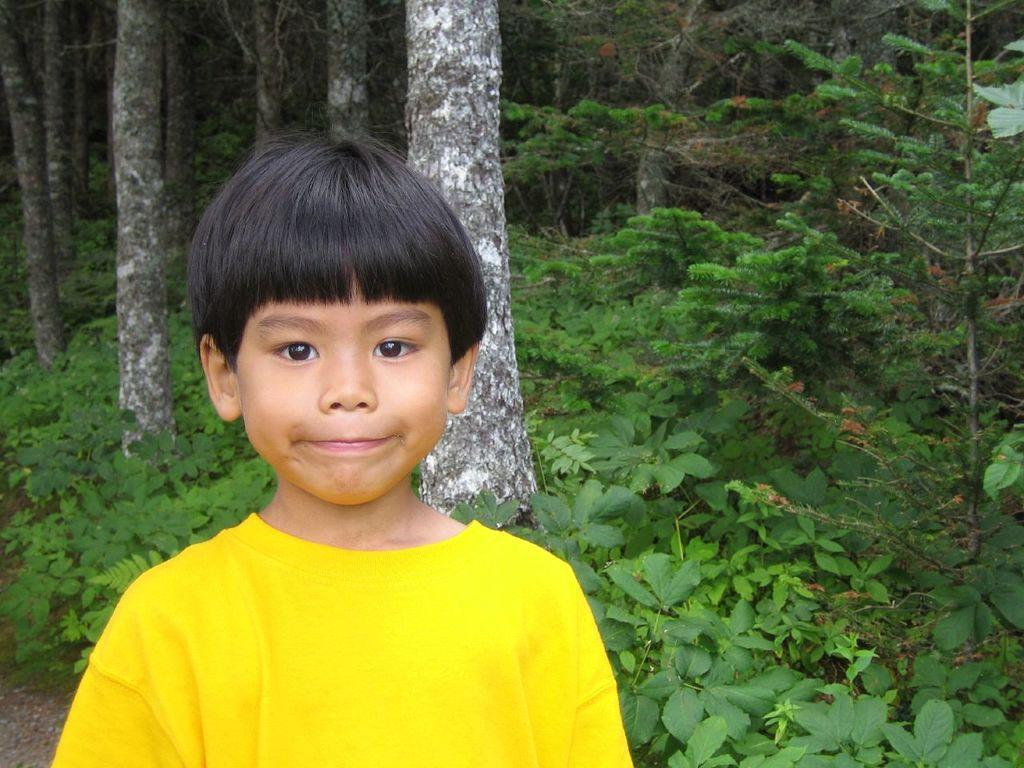What is the main subject of the image? The main subject of the image is a kid. Where is the kid located in the image? The kid is present in the middle of the image. What can be seen in the background of the image? There are trees in the background of the image. What type of breakfast is the kid eating in the image? There is no indication in the image that the kid is eating breakfast, so it cannot be determined from the picture. 